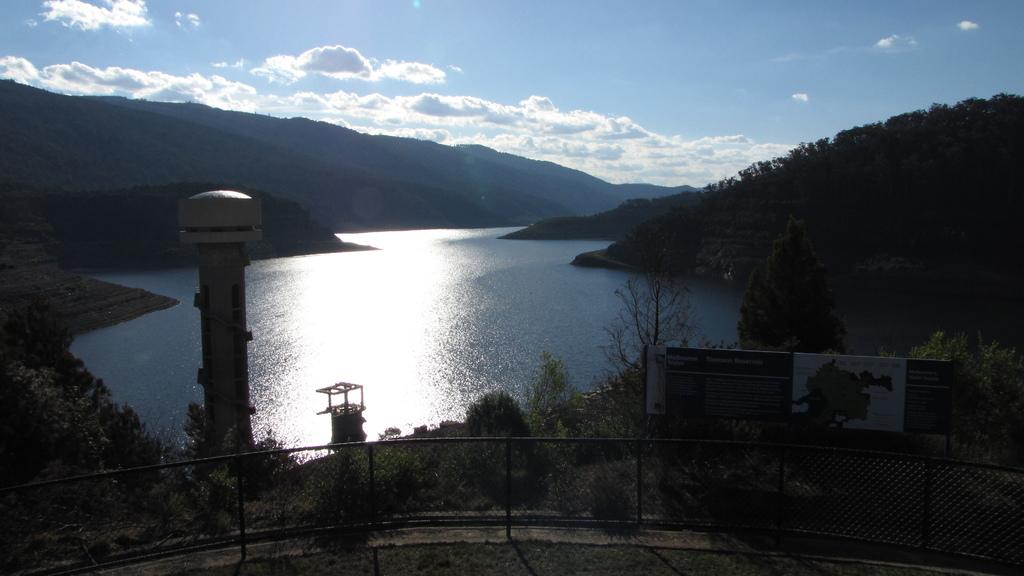What is the primary element visible in the image? Water is the primary element visible in the image. What type of natural features can be seen in the image? Hills, trees, and plants are visible in the image. What man-made structure is present in the image? There is a tower in the image. What type of barrier is at the bottom of the image? There is a fence at the bottom of the image. What object is also present at the bottom of the image? There is a board at the bottom of the image. What can be seen in the background of the image? The sky is visible in the background of the image. What type of ring can be seen on the laborer's finger in the image? There is no laborer or ring present in the image. How does the lift function in the image? There is no lift present in the image. 